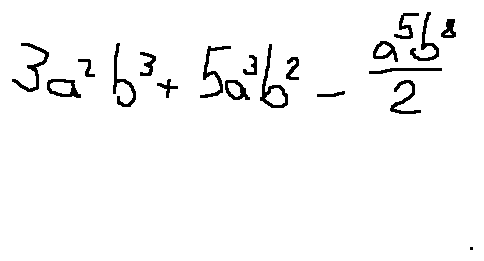Convert formula to latex. <formula><loc_0><loc_0><loc_500><loc_500>3 a ^ { 2 } b ^ { 3 } + 5 a ^ { 3 } b ^ { 2 } - \frac { a ^ { 5 } b ^ { 8 } } { 2 }</formula> 